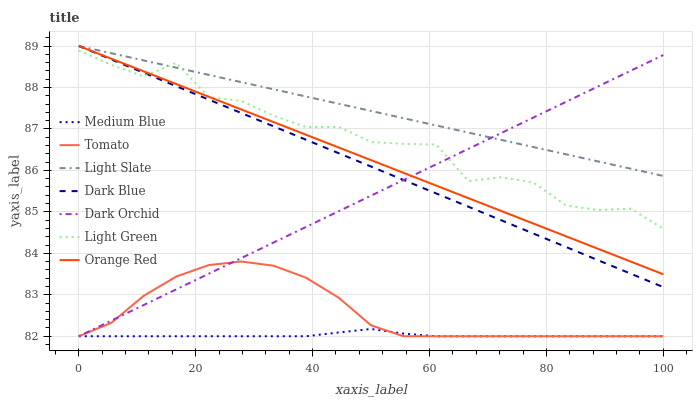Does Light Slate have the minimum area under the curve?
Answer yes or no. No. Does Medium Blue have the maximum area under the curve?
Answer yes or no. No. Is Light Slate the smoothest?
Answer yes or no. No. Is Light Slate the roughest?
Answer yes or no. No. Does Light Slate have the lowest value?
Answer yes or no. No. Does Medium Blue have the highest value?
Answer yes or no. No. Is Tomato less than Light Slate?
Answer yes or no. Yes. Is Orange Red greater than Medium Blue?
Answer yes or no. Yes. Does Tomato intersect Light Slate?
Answer yes or no. No. 